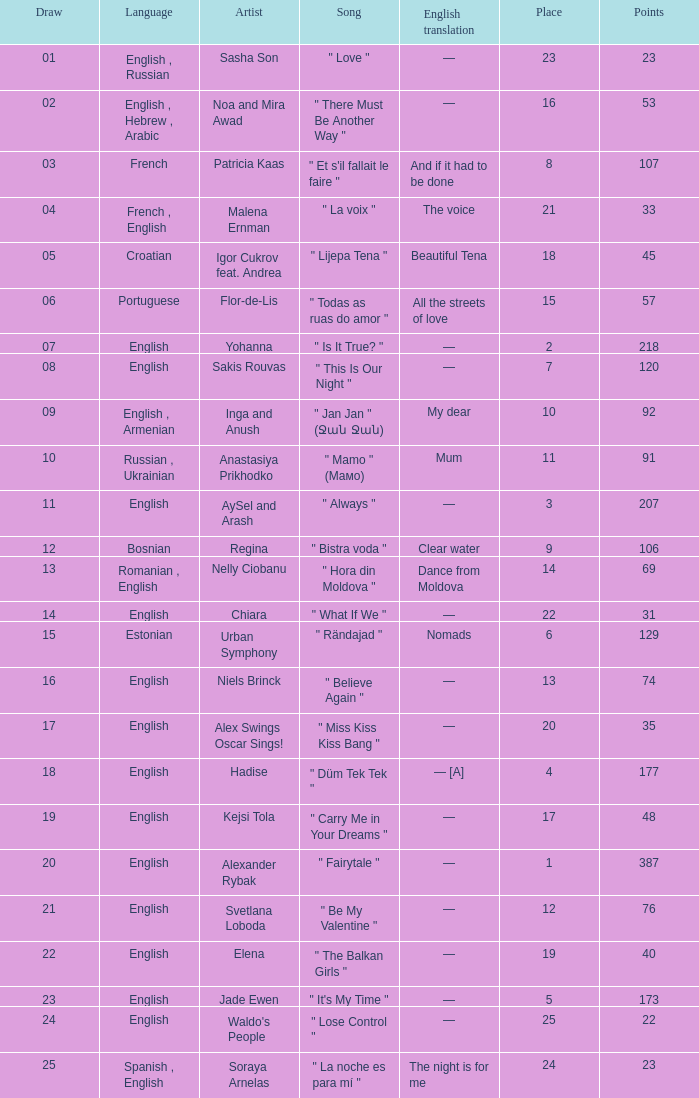What song was in french? " Et s'il fallait le faire ". Help me parse the entirety of this table. {'header': ['Draw', 'Language', 'Artist', 'Song', 'English translation', 'Place', 'Points'], 'rows': [['01', 'English , Russian', 'Sasha Son', '" Love "', '—', '23', '23'], ['02', 'English , Hebrew , Arabic', 'Noa and Mira Awad', '" There Must Be Another Way "', '—', '16', '53'], ['03', 'French', 'Patricia Kaas', '" Et s\'il fallait le faire "', 'And if it had to be done', '8', '107'], ['04', 'French , English', 'Malena Ernman', '" La voix "', 'The voice', '21', '33'], ['05', 'Croatian', 'Igor Cukrov feat. Andrea', '" Lijepa Tena "', 'Beautiful Tena', '18', '45'], ['06', 'Portuguese', 'Flor-de-Lis', '" Todas as ruas do amor "', 'All the streets of love', '15', '57'], ['07', 'English', 'Yohanna', '" Is It True? "', '—', '2', '218'], ['08', 'English', 'Sakis Rouvas', '" This Is Our Night "', '—', '7', '120'], ['09', 'English , Armenian', 'Inga and Anush', '" Jan Jan " (Ջան Ջան)', 'My dear', '10', '92'], ['10', 'Russian , Ukrainian', 'Anastasiya Prikhodko', '" Mamo " (Мамо)', 'Mum', '11', '91'], ['11', 'English', 'AySel and Arash', '" Always "', '—', '3', '207'], ['12', 'Bosnian', 'Regina', '" Bistra voda "', 'Clear water', '9', '106'], ['13', 'Romanian , English', 'Nelly Ciobanu', '" Hora din Moldova "', 'Dance from Moldova', '14', '69'], ['14', 'English', 'Chiara', '" What If We "', '—', '22', '31'], ['15', 'Estonian', 'Urban Symphony', '" Rändajad "', 'Nomads', '6', '129'], ['16', 'English', 'Niels Brinck', '" Believe Again "', '—', '13', '74'], ['17', 'English', 'Alex Swings Oscar Sings!', '" Miss Kiss Kiss Bang "', '—', '20', '35'], ['18', 'English', 'Hadise', '" Düm Tek Tek "', '— [A]', '4', '177'], ['19', 'English', 'Kejsi Tola', '" Carry Me in Your Dreams "', '—', '17', '48'], ['20', 'English', 'Alexander Rybak', '" Fairytale "', '—', '1', '387'], ['21', 'English', 'Svetlana Loboda', '" Be My Valentine "', '—', '12', '76'], ['22', 'English', 'Elena', '" The Balkan Girls "', '—', '19', '40'], ['23', 'English', 'Jade Ewen', '" It\'s My Time "', '—', '5', '173'], ['24', 'English', "Waldo's People", '" Lose Control "', '—', '25', '22'], ['25', 'Spanish , English', 'Soraya Arnelas', '" La noche es para mí "', 'The night is for me', '24', '23']]} 